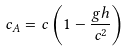Convert formula to latex. <formula><loc_0><loc_0><loc_500><loc_500>c _ { A } = c \left ( 1 - \frac { g h } { c ^ { 2 } } \right )</formula> 